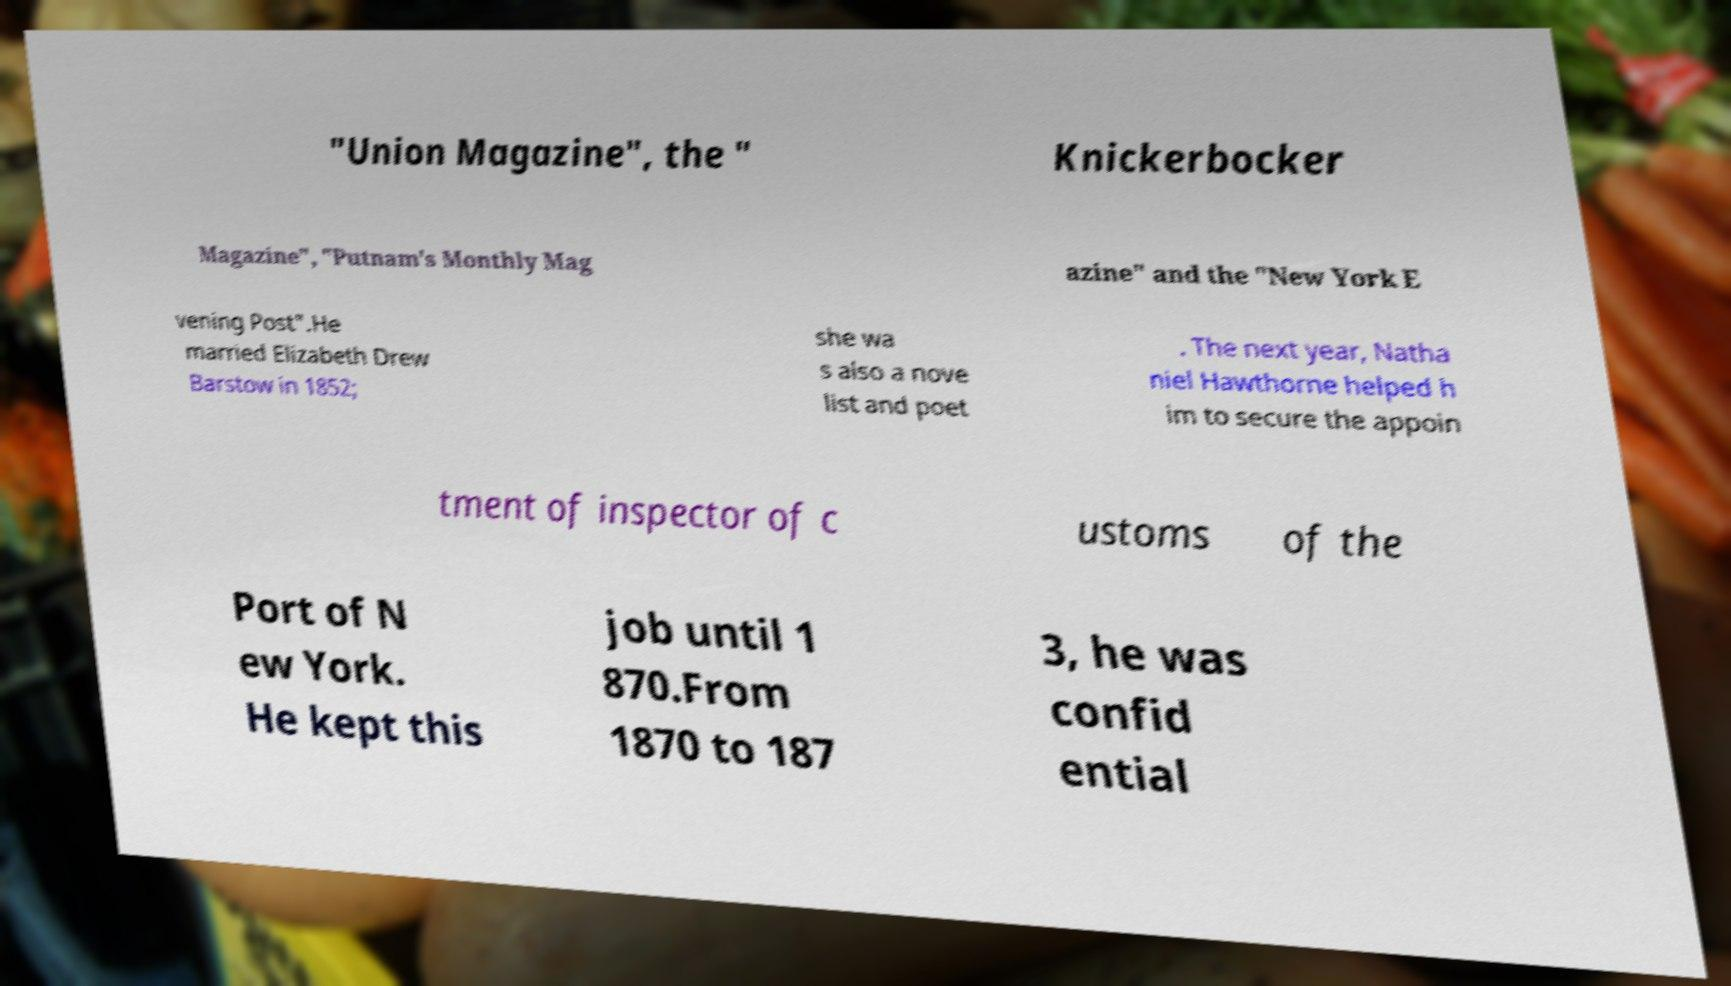Could you assist in decoding the text presented in this image and type it out clearly? "Union Magazine", the " Knickerbocker Magazine", "Putnam's Monthly Mag azine" and the "New York E vening Post".He married Elizabeth Drew Barstow in 1852; she wa s also a nove list and poet . The next year, Natha niel Hawthorne helped h im to secure the appoin tment of inspector of c ustoms of the Port of N ew York. He kept this job until 1 870.From 1870 to 187 3, he was confid ential 